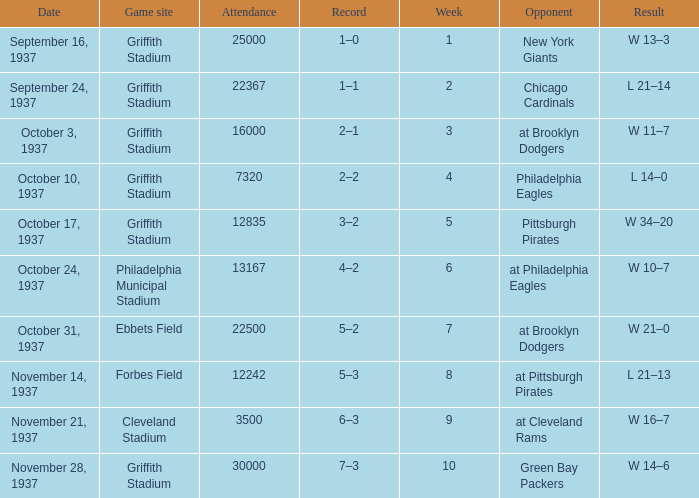What are week 4 results?  L 14–0. 